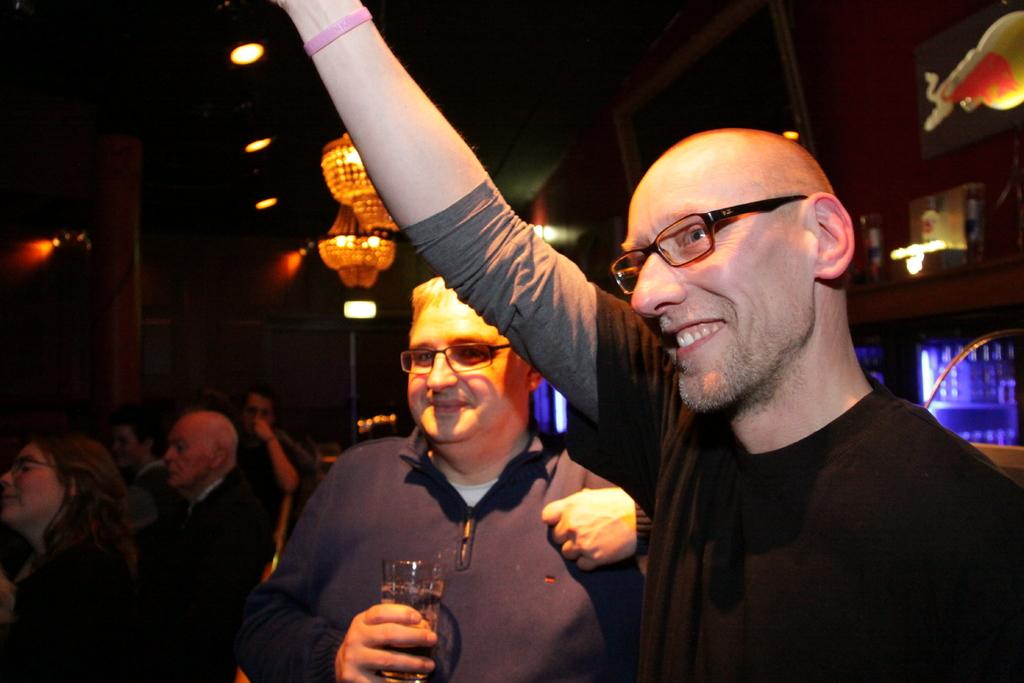What can be seen on the right side of the image? There is a person standing on the right side of the image. What is the person wearing in the image? The person is wearing a T-shirt in the image. What is located in the middle of the image? There is a light in the middle of the image. Can you describe the coastline visible in the image? There is no coastline visible in the image; it features a person standing on the right side, a T-shirt, and a light in the middle. 